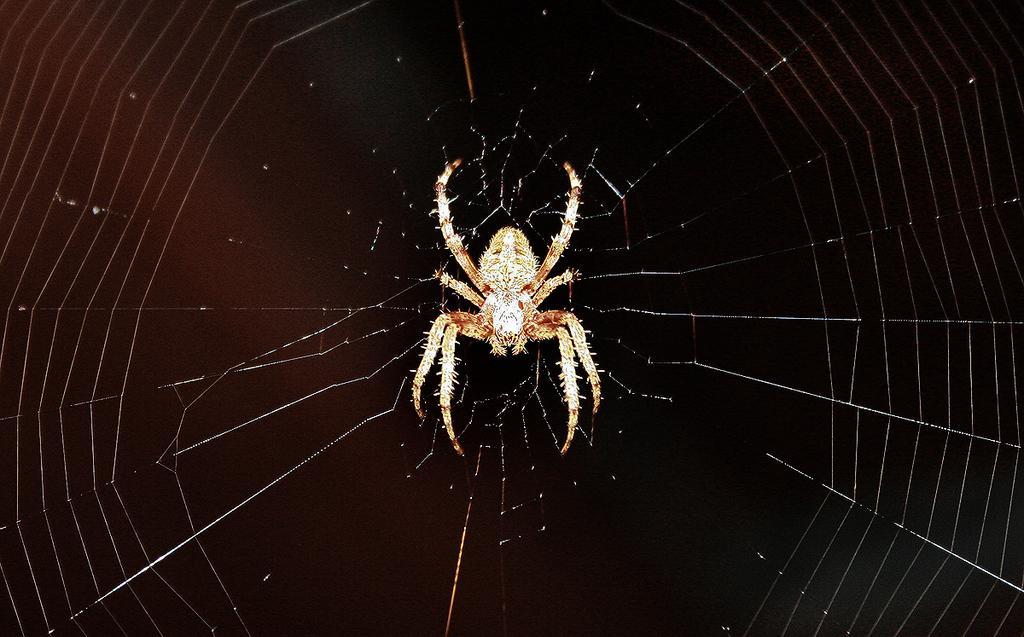Can you describe this image briefly? Here we can see spider and spider web. Background it is dark. 